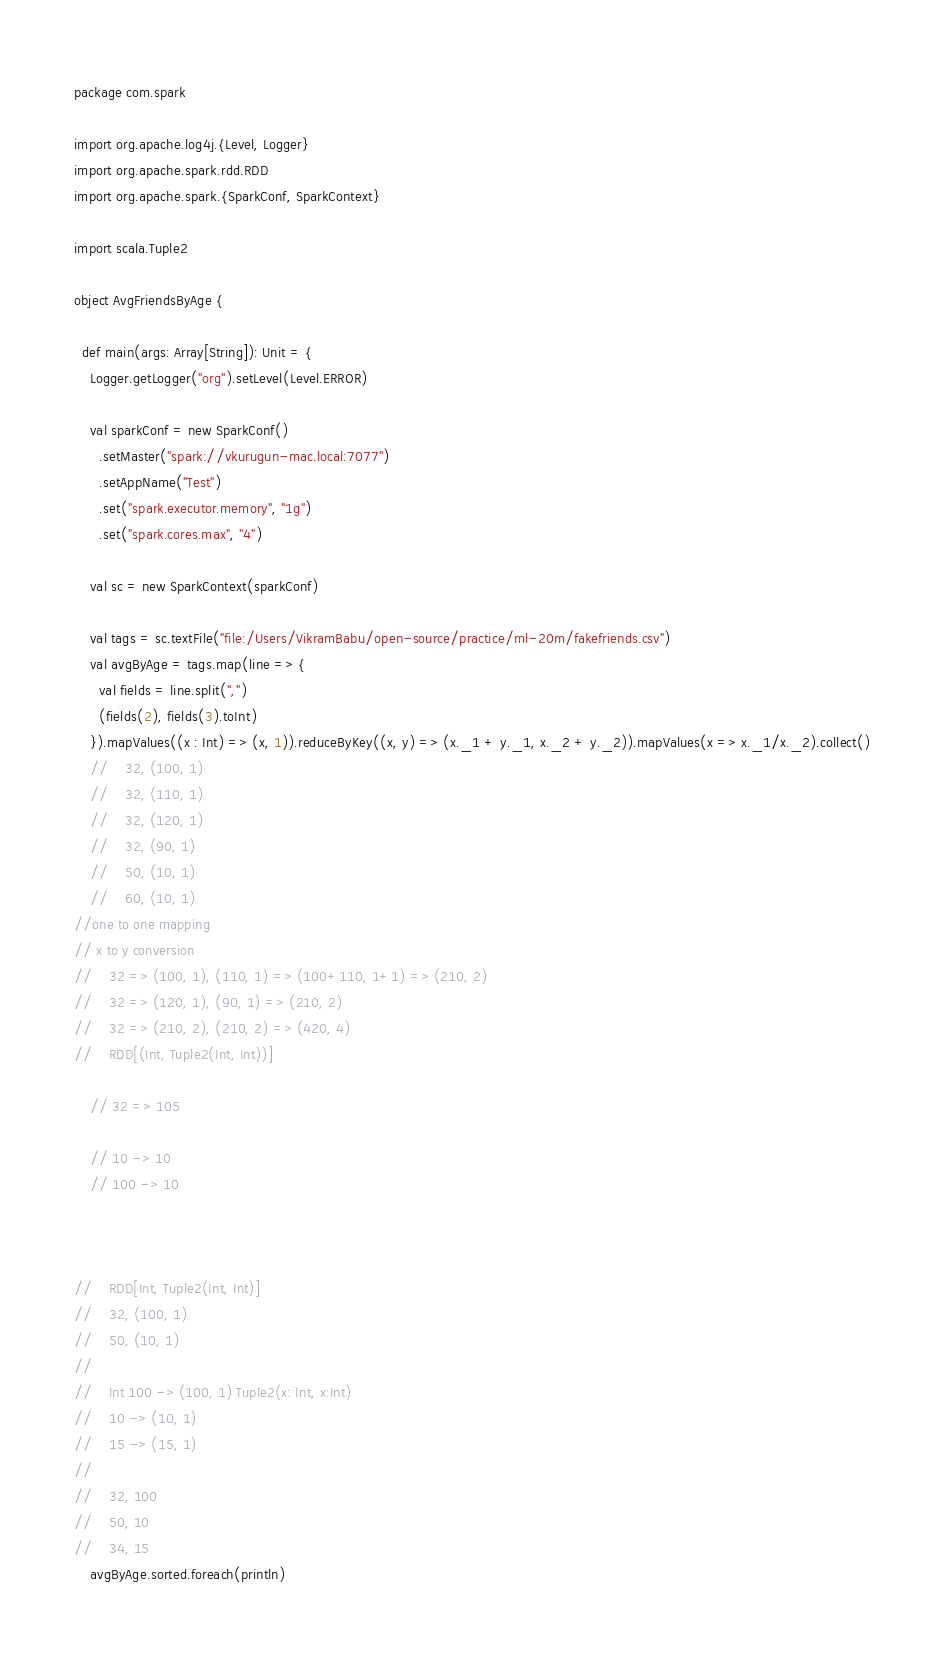<code> <loc_0><loc_0><loc_500><loc_500><_Scala_>package com.spark

import org.apache.log4j.{Level, Logger}
import org.apache.spark.rdd.RDD
import org.apache.spark.{SparkConf, SparkContext}

import scala.Tuple2

object AvgFriendsByAge {

  def main(args: Array[String]): Unit = {
    Logger.getLogger("org").setLevel(Level.ERROR)

    val sparkConf = new SparkConf()
      .setMaster("spark://vkurugun-mac.local:7077")
      .setAppName("Test")
      .set("spark.executor.memory", "1g")
      .set("spark.cores.max", "4")

    val sc = new SparkContext(sparkConf)

    val tags = sc.textFile("file:/Users/VikramBabu/open-source/practice/ml-20m/fakefriends.csv")
    val avgByAge = tags.map(line => {
      val fields = line.split(",")
      (fields(2), fields(3).toInt)
    }).mapValues((x : Int) => (x, 1)).reduceByKey((x, y) => (x._1 + y._1, x._2 + y._2)).mapValues(x => x._1/x._2).collect()
    //    32, (100, 1)
    //    32, (110, 1)
    //    32, (120, 1)
    //    32, (90, 1)
    //    50, (10, 1)
    //    60, (10, 1)
//one to one mapping
// x to y conversion
//    32 => (100, 1), (110, 1) => (100+110, 1+1) => (210, 2)
//    32 => (120, 1), (90, 1) => (210, 2)
//    32 => (210, 2), (210, 2) => (420, 4)
//    RDD[(Int, Tuple2(Int, Int))]

    // 32 => 105

    // 10 -> 10
    // 100 -> 10



//    RDD[Int, Tuple2(Int, Int)]
//    32, (100, 1)
//    50, (10, 1)
//
//    Int 100 -> (100, 1) Tuple2(x: Int, x:Int)
//    10 -> (10, 1)
//    15 -> (15, 1)
//
//    32, 100
//    50, 10
//    34, 15
    avgByAge.sorted.foreach(println)</code> 